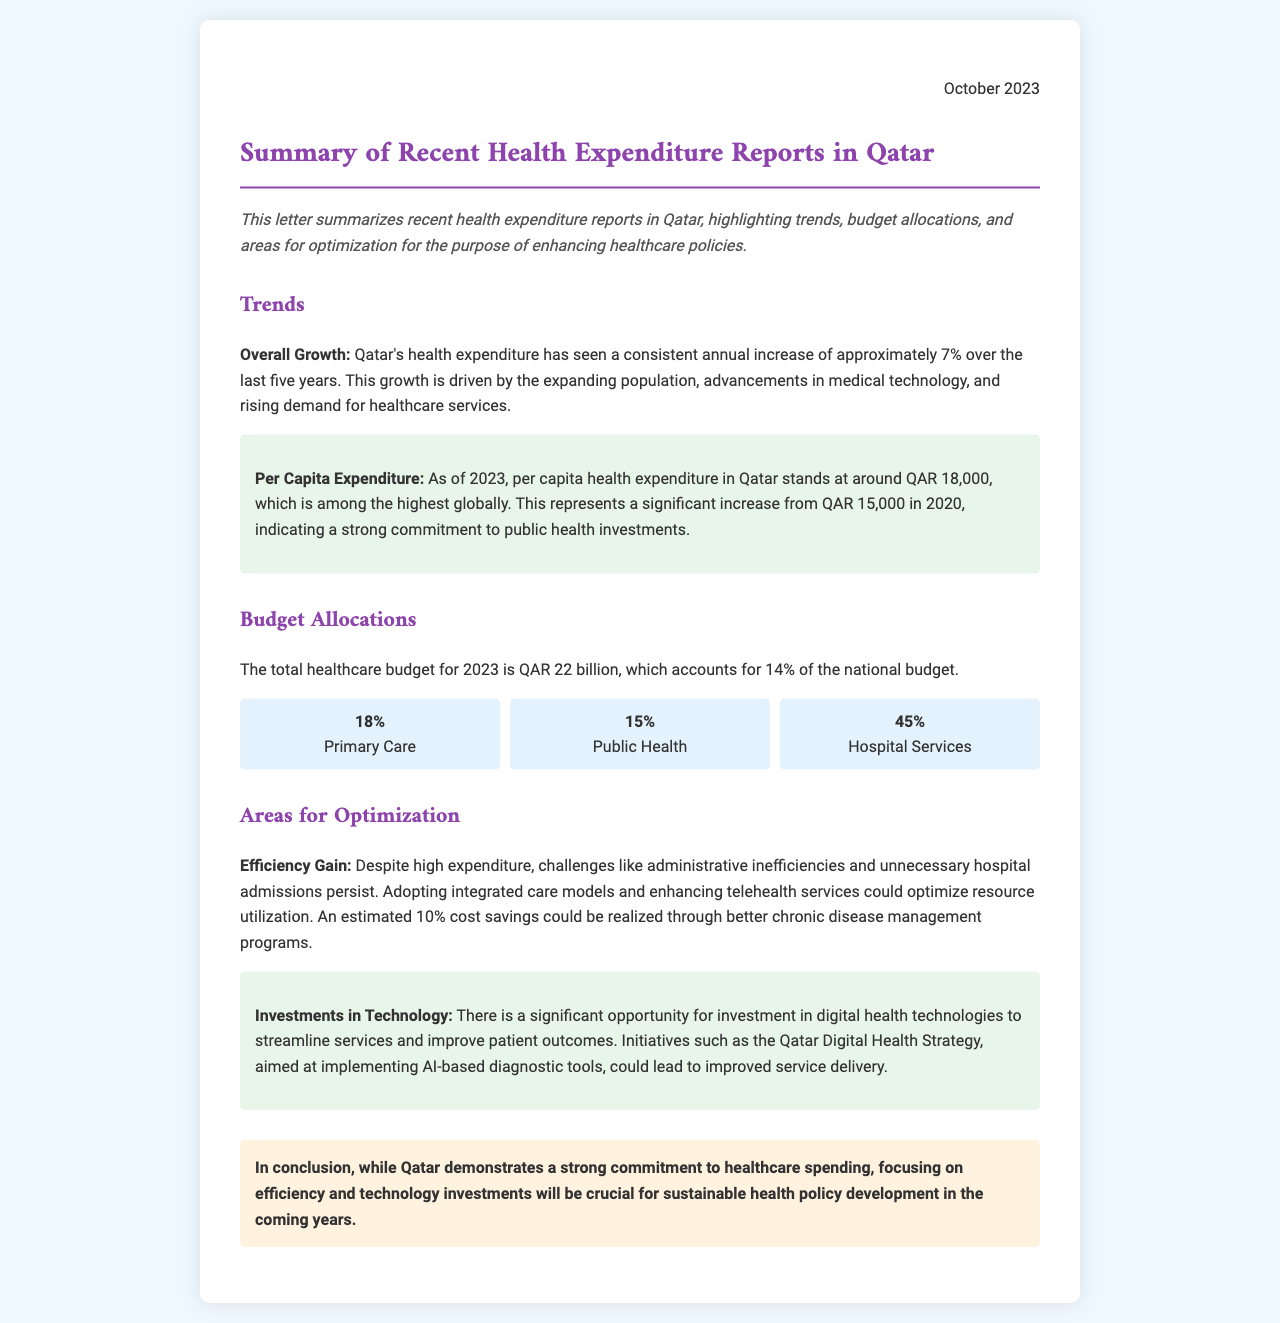What is the annual growth rate of Qatar's health expenditure? The document states that Qatar's health expenditure has seen a consistent annual increase of approximately 7% over the last five years.
Answer: 7% What was the per capita health expenditure in 2020? According to the document, the per capita health expenditure in Qatar was QAR 15,000 in 2020.
Answer: QAR 15,000 What percentage of the national budget is allocated to healthcare in 2023? The healthcare budget for 2023 accounts for 14% of the national budget.
Answer: 14% What is the total healthcare budget for 2023? The document mentions that the total healthcare budget for 2023 is QAR 22 billion.
Answer: QAR 22 billion What percentage of the budget is allocated to hospital services? The document states that 45% of the budget is allocated to hospital services.
Answer: 45% What is one suggested area for optimization in healthcare spending? The document mentions enhancing telehealth services as one area for optimization.
Answer: Telehealth services What is one potential efficiency gain mentioned in the document? The document highlights that better chronic disease management programs could realize an estimated 10% cost savings.
Answer: 10% What technology investment opportunity is highlighted in the letter? The letter emphasizes investments in digital health technologies for streamlining services.
Answer: Digital health technologies When was this health expenditure summary letter published? The document indicates that the summary was published in October 2023.
Answer: October 2023 